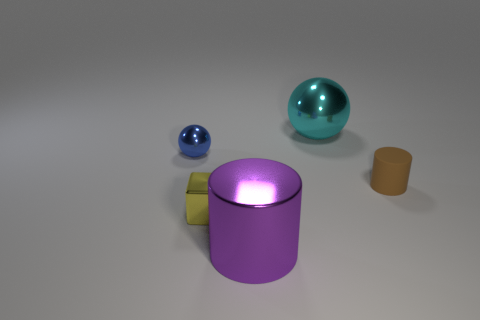Can you guess which object is the heaviest? If we base our guess purely on the size and appearance of the objects, the purple cylinder appears to be the largest and possibly the heaviest object in the image, followed by the teal sphere, the tiny blue ball, and finally the small block, which looks like it could be the lightest. Is there a characteristic that indicates why that object would be heavier? Generally, an object's weight is influenced by both its volume and the density of the material it is made from. The purple cylinder's size suggests it has the greatest volume, and if all objects are made of materials with similar densities, it would likely be the heaviest. 